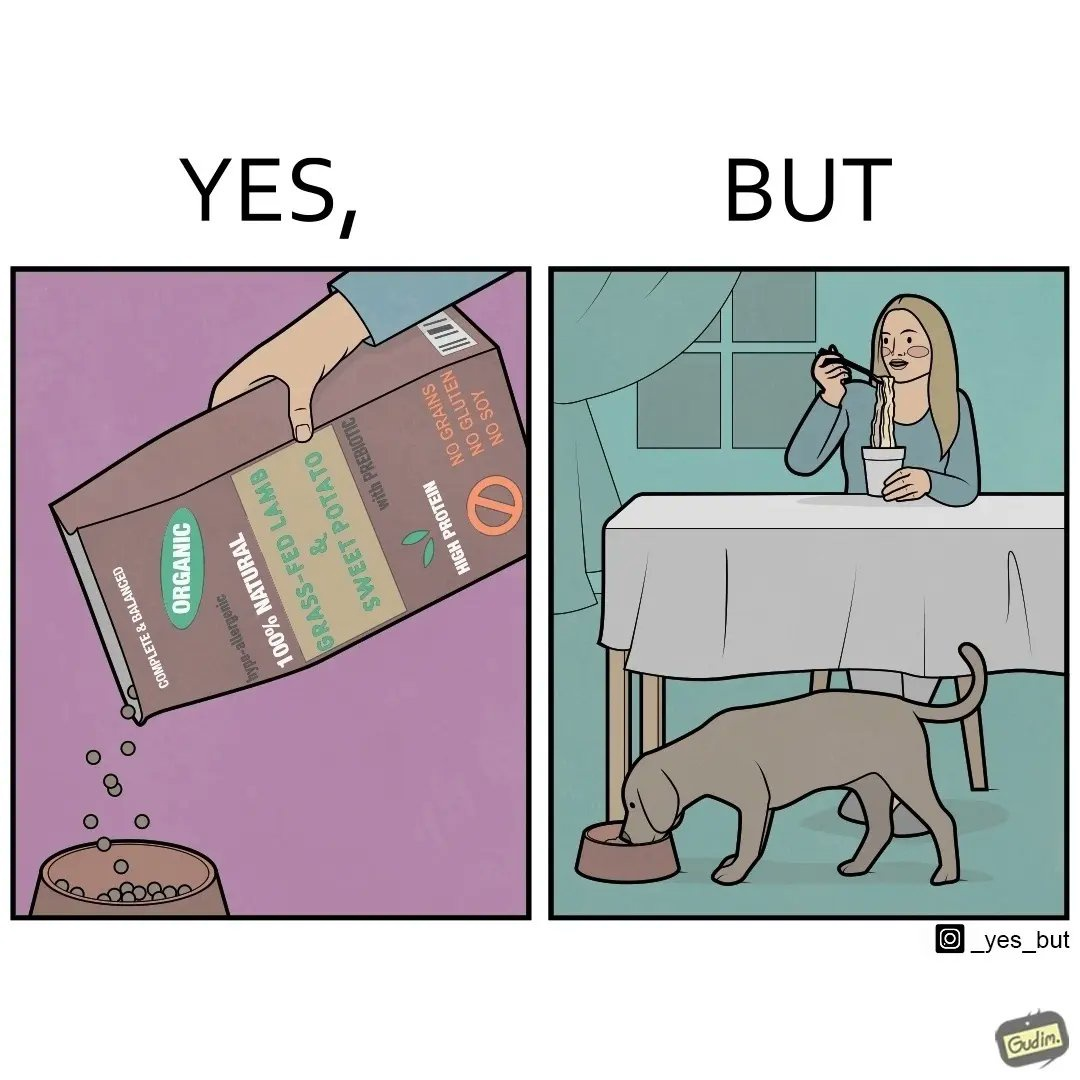Describe what you see in this image. The image is funny because while the food for the dog that the woman pours is well balanced, the food that she herself is eating is bad for her health. 